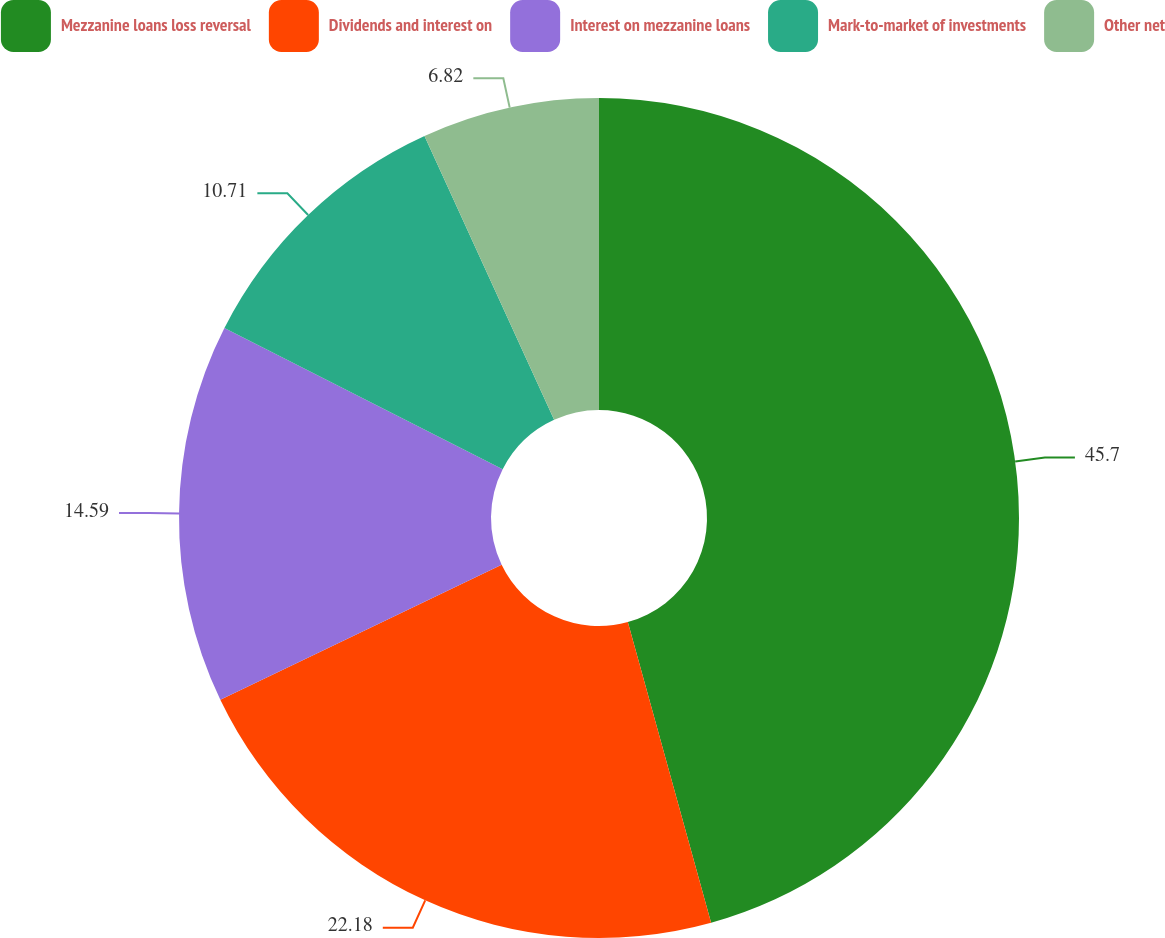Convert chart. <chart><loc_0><loc_0><loc_500><loc_500><pie_chart><fcel>Mezzanine loans loss reversal<fcel>Dividends and interest on<fcel>Interest on mezzanine loans<fcel>Mark-to-market of investments<fcel>Other net<nl><fcel>45.7%<fcel>22.18%<fcel>14.59%<fcel>10.71%<fcel>6.82%<nl></chart> 